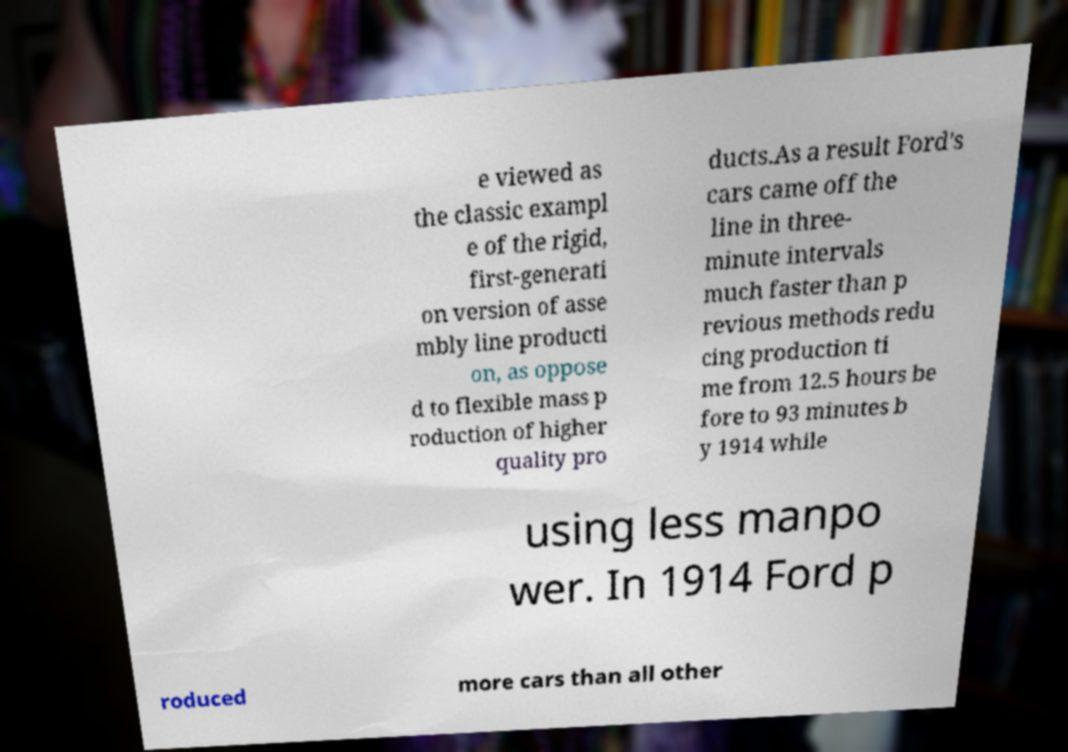I need the written content from this picture converted into text. Can you do that? e viewed as the classic exampl e of the rigid, first-generati on version of asse mbly line producti on, as oppose d to flexible mass p roduction of higher quality pro ducts.As a result Ford's cars came off the line in three- minute intervals much faster than p revious methods redu cing production ti me from 12.5 hours be fore to 93 minutes b y 1914 while using less manpo wer. In 1914 Ford p roduced more cars than all other 